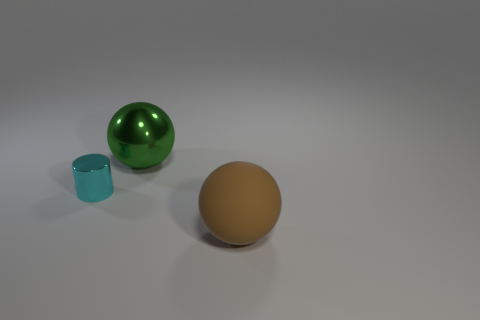Add 1 cyan cylinders. How many objects exist? 4 Subtract all green balls. Subtract all red cubes. How many balls are left? 1 Subtract all brown cylinders. How many brown balls are left? 1 Subtract all tiny red metal cubes. Subtract all large shiny balls. How many objects are left? 2 Add 2 shiny cylinders. How many shiny cylinders are left? 3 Add 1 brown spheres. How many brown spheres exist? 2 Subtract 0 yellow blocks. How many objects are left? 3 Subtract all balls. How many objects are left? 1 Subtract 2 spheres. How many spheres are left? 0 